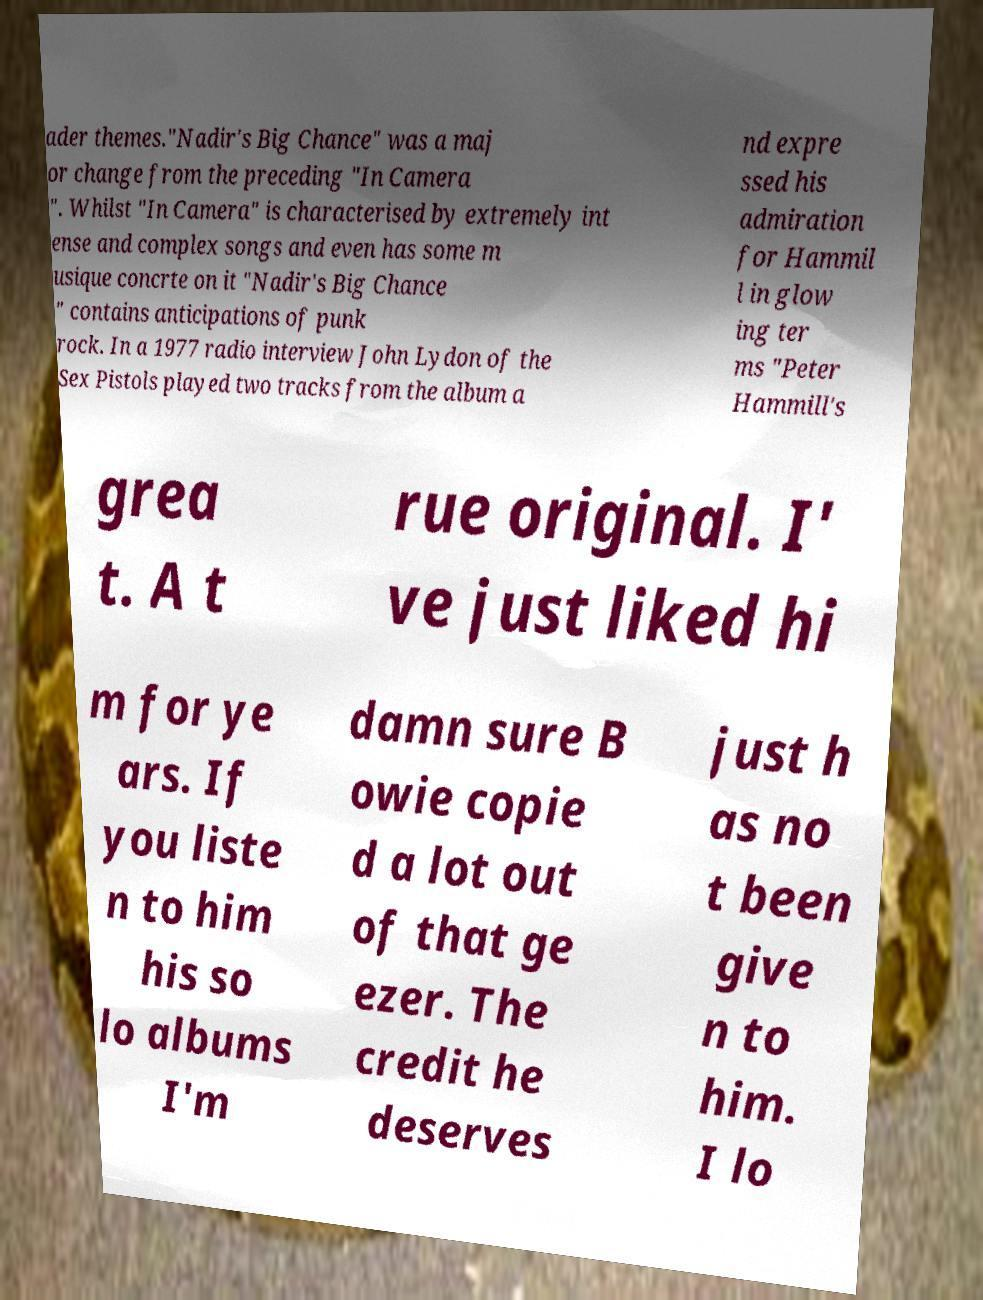Please identify and transcribe the text found in this image. ader themes."Nadir's Big Chance" was a maj or change from the preceding "In Camera ". Whilst "In Camera" is characterised by extremely int ense and complex songs and even has some m usique concrte on it "Nadir's Big Chance " contains anticipations of punk rock. In a 1977 radio interview John Lydon of the Sex Pistols played two tracks from the album a nd expre ssed his admiration for Hammil l in glow ing ter ms "Peter Hammill's grea t. A t rue original. I' ve just liked hi m for ye ars. If you liste n to him his so lo albums I'm damn sure B owie copie d a lot out of that ge ezer. The credit he deserves just h as no t been give n to him. I lo 